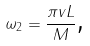<formula> <loc_0><loc_0><loc_500><loc_500>\omega _ { 2 } = \frac { \pi v L } { M } \text {,}</formula> 